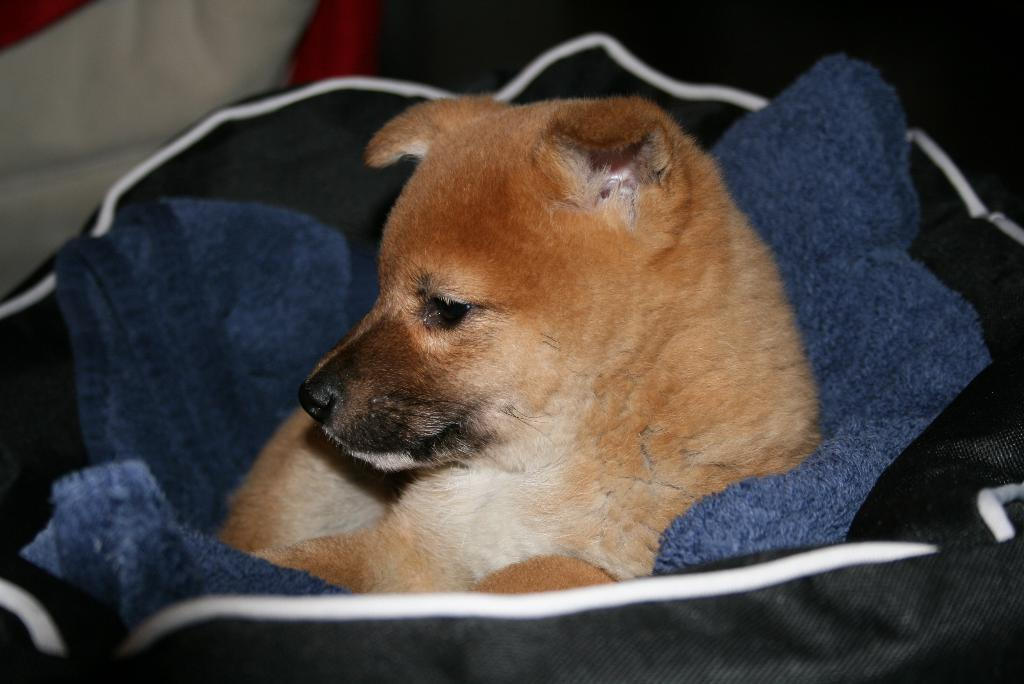What is the main subject of the picture? There is a puppy in the picture. Where is the puppy located in the picture? The puppy is in the middle of the picture. What colors can be seen on the puppy? The puppy has brown and white colors. How would you describe the background of the picture? The background of the picture is blurred. How many mice are playing with the puppy's feet in the image? There are no mice or feet visible in the image; it only features a puppy. 